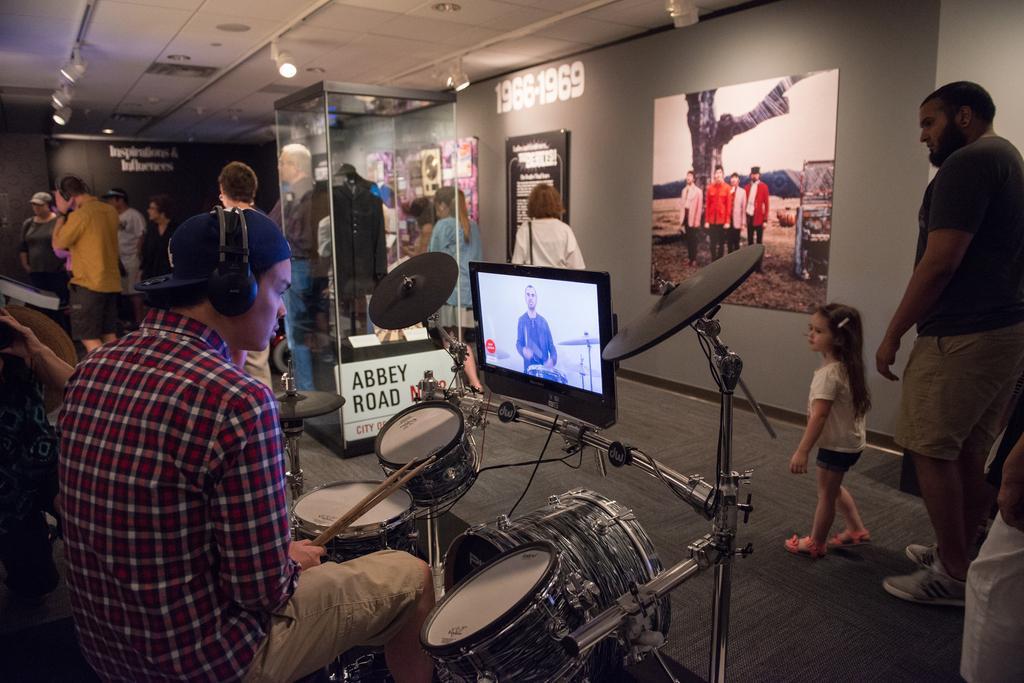Can you describe this image briefly? In this picture we can see a group of people where there men wore cap, headset holding sticks in his hand and looking at screen and in front of him we have drums and in background we can see some more persons, wall with frame, lights. 